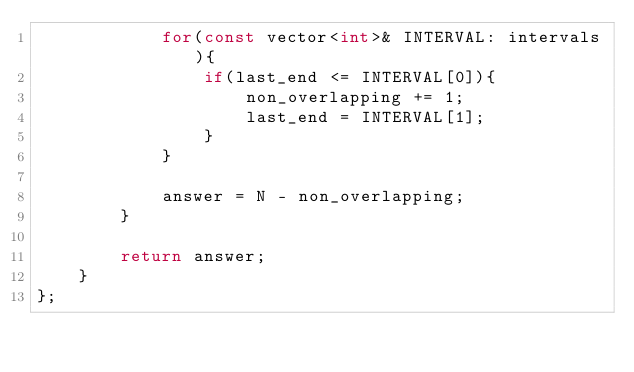Convert code to text. <code><loc_0><loc_0><loc_500><loc_500><_C++_>            for(const vector<int>& INTERVAL: intervals){
                if(last_end <= INTERVAL[0]){
                    non_overlapping += 1;
                    last_end = INTERVAL[1];
                }
            }
            
            answer = N - non_overlapping;
        }
        
        return answer;
    }
};</code> 